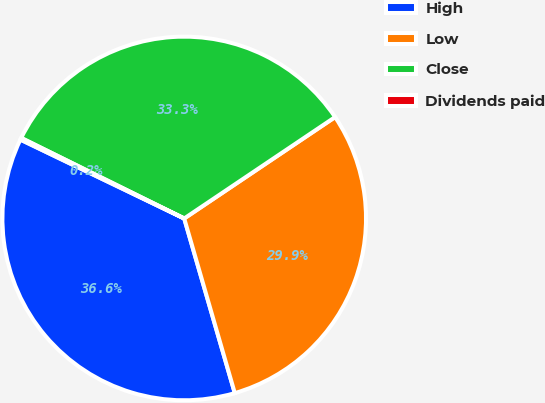Convert chart to OTSL. <chart><loc_0><loc_0><loc_500><loc_500><pie_chart><fcel>High<fcel>Low<fcel>Close<fcel>Dividends paid<nl><fcel>36.63%<fcel>29.93%<fcel>33.28%<fcel>0.16%<nl></chart> 